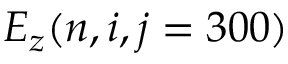Convert formula to latex. <formula><loc_0><loc_0><loc_500><loc_500>E _ { z } ( n , i , j = 3 0 0 )</formula> 